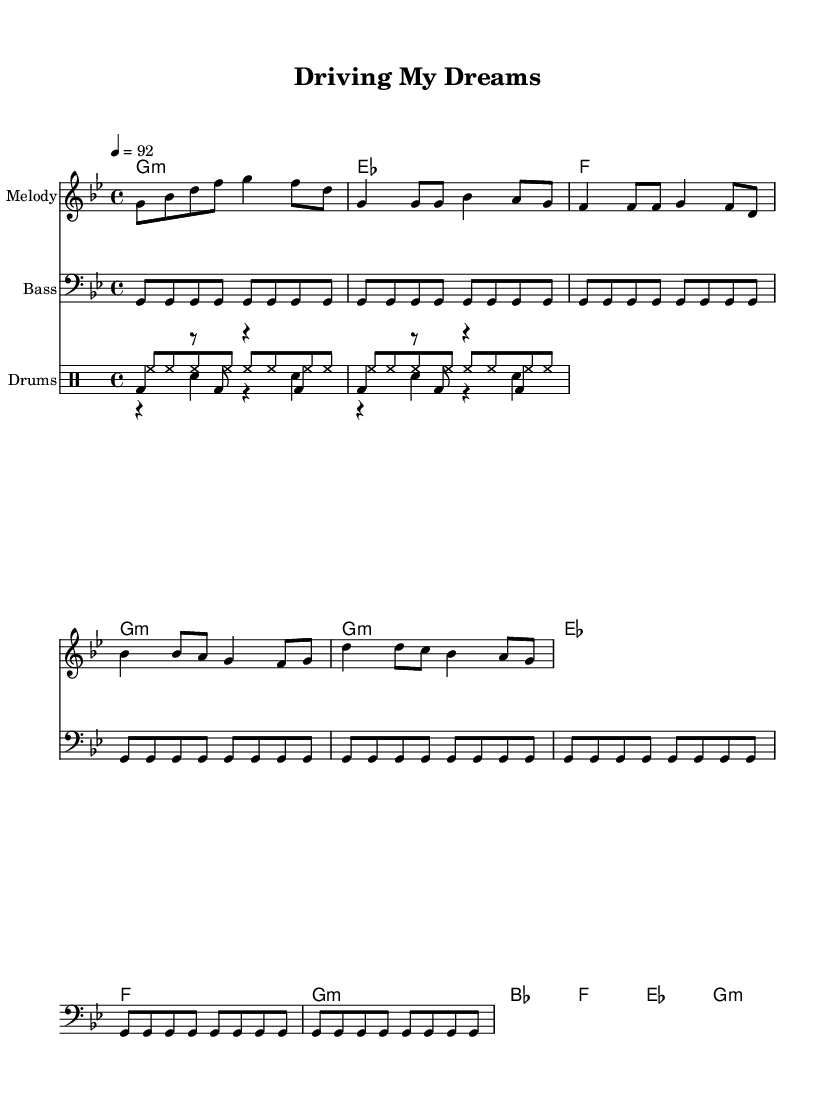What is the key signature of this music? The key signature is G minor, which has two flats (B♭ and E♭). This can be identified by looking at the written sharps or flats at the beginning of the staff.
Answer: G minor What is the time signature of this music? The time signature is 4/4, which means there are four beats in each measure and the quarter note gets one beat. This is indicated at the beginning of the score.
Answer: 4/4 What is the tempo marking for this piece? The tempo marking is 92 beats per minute, indicated by the number and note value just before the melody starts.
Answer: 92 How many measures are in the verse section? The verse section contains 4 measures as observed in the layout of the melody where phrases are grouped into measures. To count, we look at the structure of the verse lyrics and where the music notes stop.
Answer: 4 What instrument is the melody written for? The melody is written for a piano or lead instrument, indicated by the staff labeled "Melody" at the beginning of the score.
Answer: Melody Which drum pattern is used in this sheet music? The drum patterns include a kick pattern, snare pattern, and hi-hat pattern, each labeled separately within the drum staff. The kick pattern is highlighted with the base drum labeled as 'bd', the snare as 'sn', and hi-hats as 'hh'.
Answer: Kick, snare, and hi-hat What message does the chorus convey? The chorus conveys a message of determination and pride in one's profession, expressing a strong motivational theme. This can be derived from the emphasis in the lyrics as they talk about "driving dreams" and overcoming challenges.
Answer: Motivational pride 